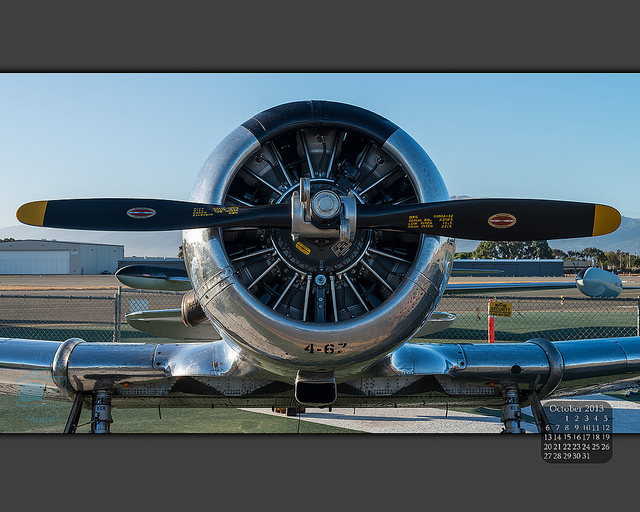Please identify all text content in this image. 4 67 31 30 28 27 26 25 24 23 22 121 20 19 18 17 16 15 14 13 12 10 9 8 7 6 4 3 2 I 2013 